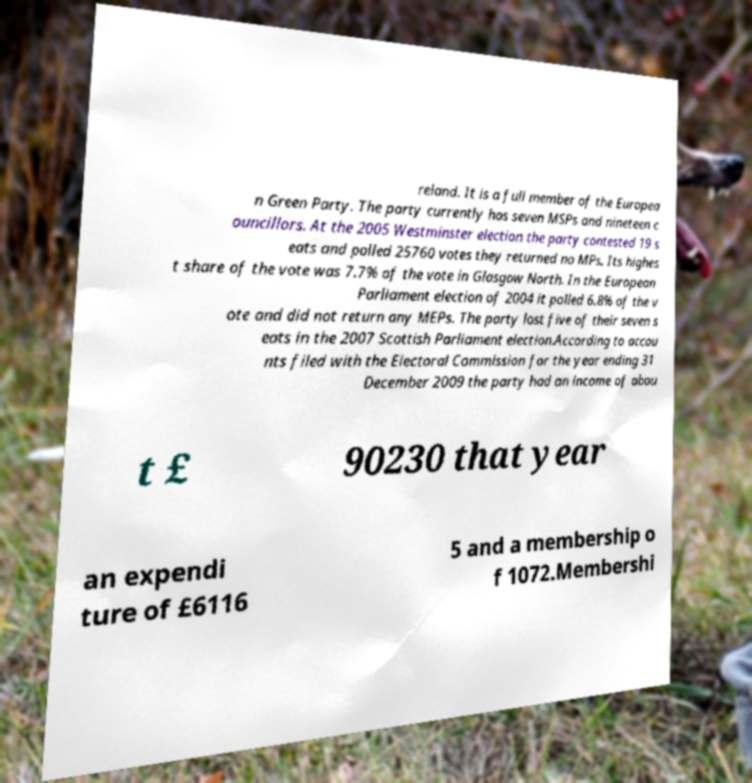There's text embedded in this image that I need extracted. Can you transcribe it verbatim? reland. It is a full member of the Europea n Green Party. The party currently has seven MSPs and nineteen c ouncillors. At the 2005 Westminster election the party contested 19 s eats and polled 25760 votes they returned no MPs. Its highes t share of the vote was 7.7% of the vote in Glasgow North. In the European Parliament election of 2004 it polled 6.8% of the v ote and did not return any MEPs. The party lost five of their seven s eats in the 2007 Scottish Parliament election.According to accou nts filed with the Electoral Commission for the year ending 31 December 2009 the party had an income of abou t £ 90230 that year an expendi ture of £6116 5 and a membership o f 1072.Membershi 